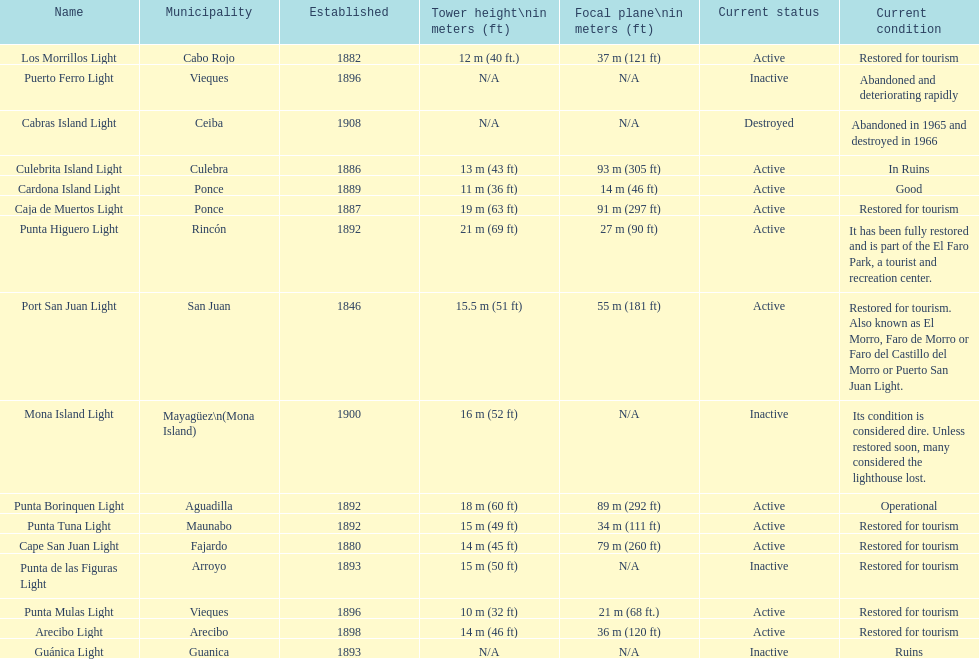Names of municipalities established before 1880 San Juan. 